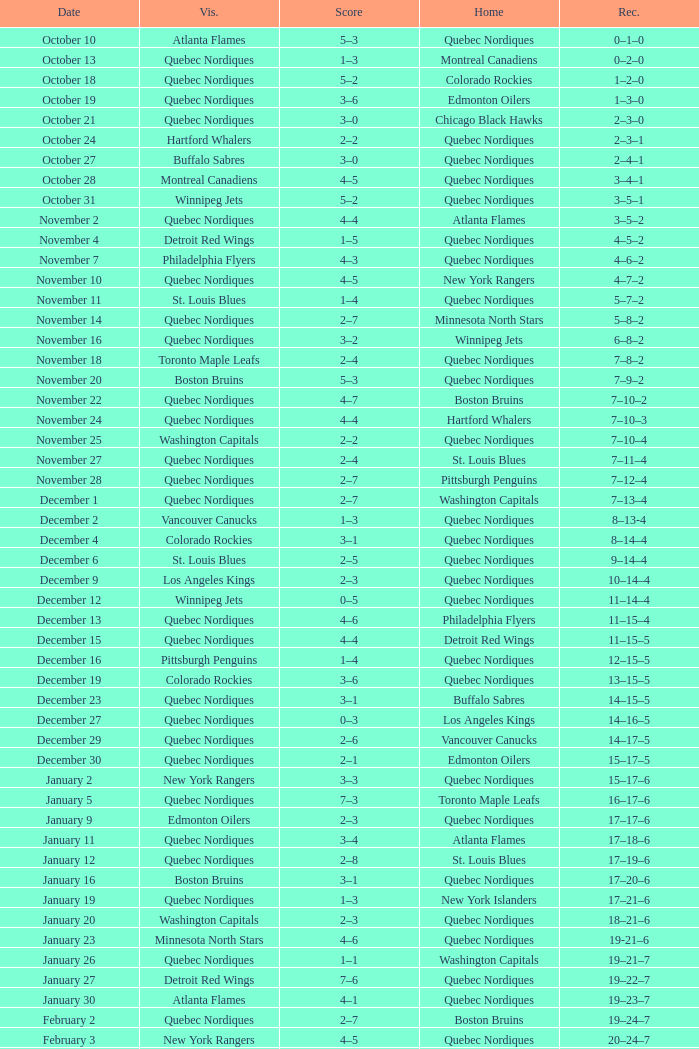Which Home has a Date of april 1? Quebec Nordiques. 